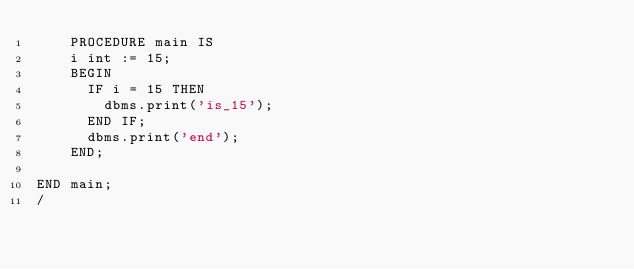Convert code to text. <code><loc_0><loc_0><loc_500><loc_500><_SQL_>    PROCEDURE main IS
    i int := 15;
    BEGIN
      IF i = 15 THEN
        dbms.print('is_15');
      END IF;
      dbms.print('end');
    END;

END main;
/
</code> 